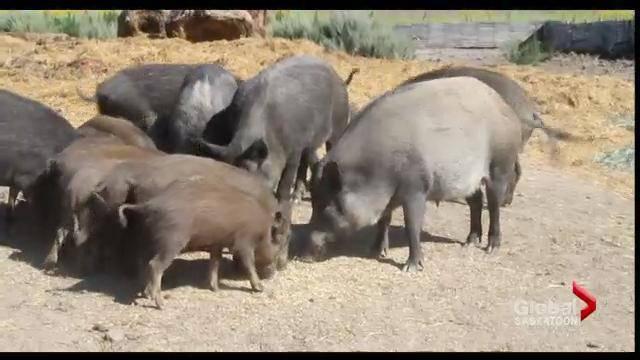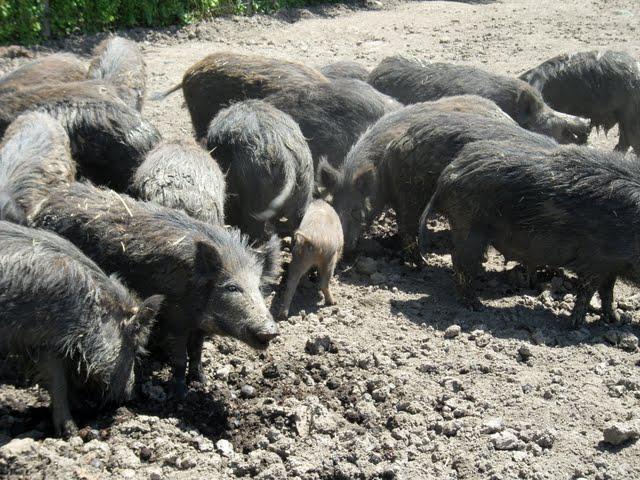The first image is the image on the left, the second image is the image on the right. Considering the images on both sides, is "The left photo contains two or fewer boars." valid? Answer yes or no. No. The first image is the image on the left, the second image is the image on the right. Analyze the images presented: Is the assertion "The left image contains no more than two wild boars." valid? Answer yes or no. No. 